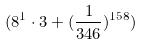<formula> <loc_0><loc_0><loc_500><loc_500>( 8 ^ { 1 } \cdot 3 + ( \frac { 1 } { 3 4 6 } ) ^ { 1 5 8 } )</formula> 